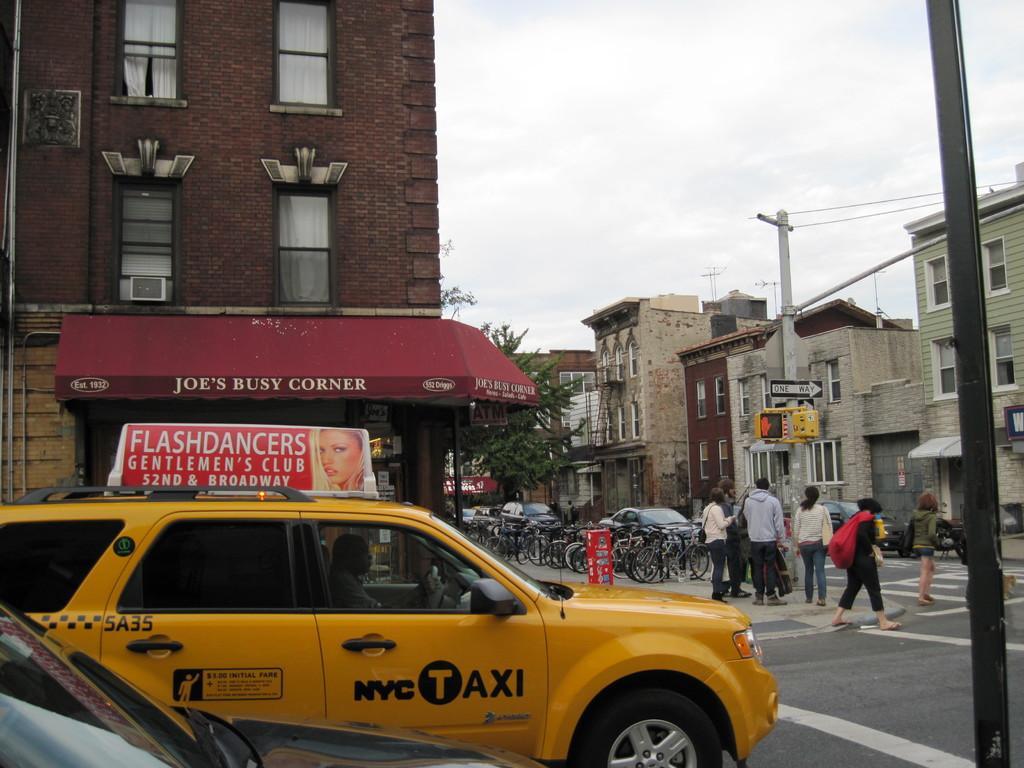In one or two sentences, can you explain what this image depicts? At the bottom there is a car in yellow color, on the right side few persons are walking on the road, there are houses. in the middle there is the sky. 